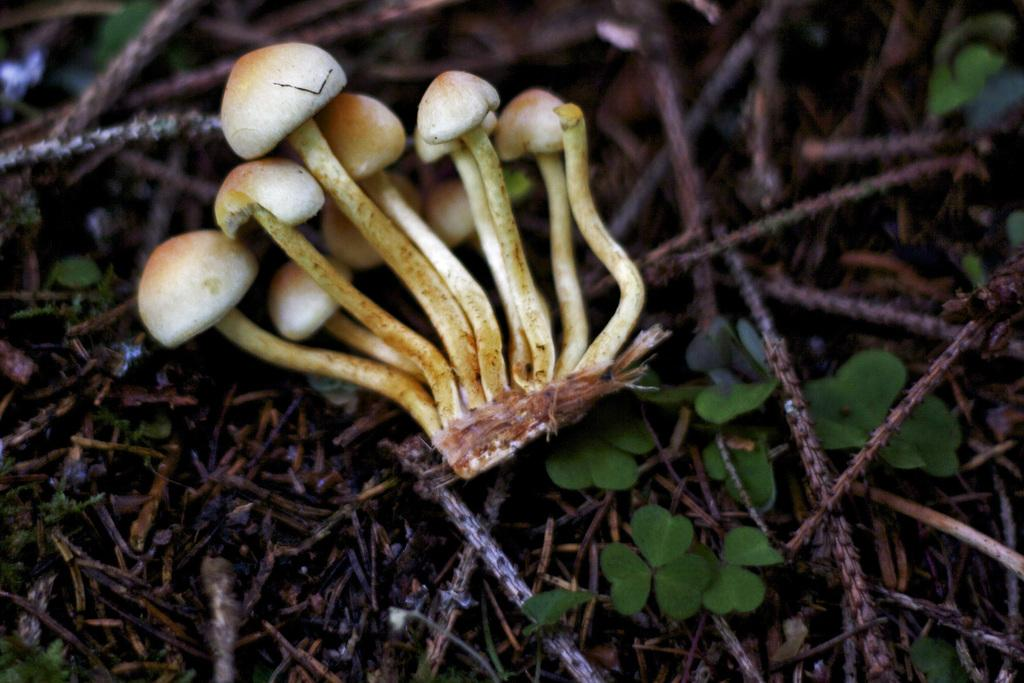What type of vegetation can be seen on the ground in the image? There are small mushrooms on the ground in the image. What else can be seen on the ground besides the mushrooms? There are dried stems in the image. Are there any other plant-related items visible in the image? Yes, there are small leaves in the image. How many pizzas are being held by the parent in the image? There are no pizzas or parents present in the image; it features small mushrooms, dried stems, and small leaves. 